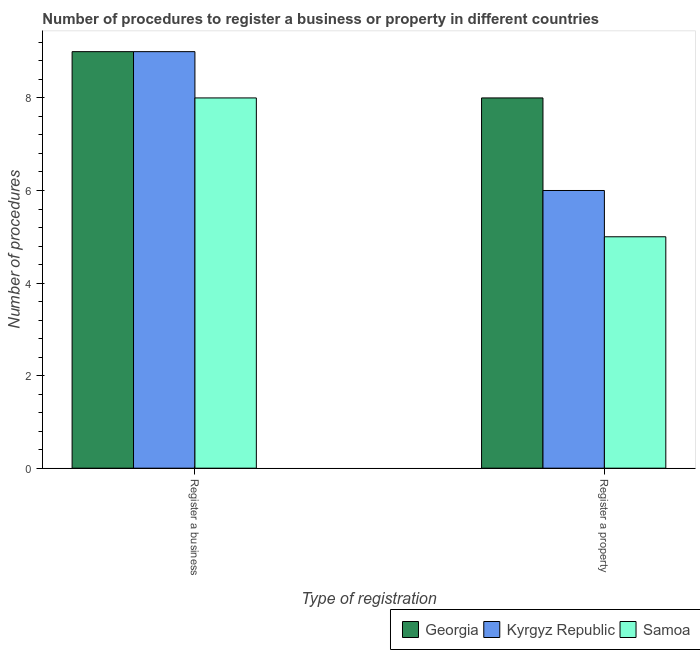How many groups of bars are there?
Provide a short and direct response. 2. Are the number of bars on each tick of the X-axis equal?
Provide a short and direct response. Yes. What is the label of the 1st group of bars from the left?
Give a very brief answer. Register a business. What is the number of procedures to register a business in Samoa?
Make the answer very short. 8. Across all countries, what is the maximum number of procedures to register a property?
Ensure brevity in your answer.  8. Across all countries, what is the minimum number of procedures to register a property?
Give a very brief answer. 5. In which country was the number of procedures to register a business maximum?
Your response must be concise. Georgia. In which country was the number of procedures to register a business minimum?
Keep it short and to the point. Samoa. What is the total number of procedures to register a property in the graph?
Keep it short and to the point. 19. What is the difference between the number of procedures to register a property in Samoa and that in Kyrgyz Republic?
Give a very brief answer. -1. What is the difference between the number of procedures to register a business in Georgia and the number of procedures to register a property in Kyrgyz Republic?
Keep it short and to the point. 3. What is the average number of procedures to register a business per country?
Provide a short and direct response. 8.67. What is the difference between the number of procedures to register a property and number of procedures to register a business in Kyrgyz Republic?
Offer a very short reply. -3. What is the ratio of the number of procedures to register a business in Samoa to that in Kyrgyz Republic?
Your answer should be compact. 0.89. Is the number of procedures to register a property in Kyrgyz Republic less than that in Georgia?
Your answer should be compact. Yes. In how many countries, is the number of procedures to register a property greater than the average number of procedures to register a property taken over all countries?
Give a very brief answer. 1. What does the 1st bar from the left in Register a business represents?
Offer a very short reply. Georgia. What does the 1st bar from the right in Register a property represents?
Your response must be concise. Samoa. How many countries are there in the graph?
Provide a short and direct response. 3. Are the values on the major ticks of Y-axis written in scientific E-notation?
Your response must be concise. No. What is the title of the graph?
Ensure brevity in your answer.  Number of procedures to register a business or property in different countries. Does "Russian Federation" appear as one of the legend labels in the graph?
Offer a terse response. No. What is the label or title of the X-axis?
Provide a short and direct response. Type of registration. What is the label or title of the Y-axis?
Keep it short and to the point. Number of procedures. What is the Number of procedures in Georgia in Register a property?
Provide a succinct answer. 8. What is the Number of procedures in Kyrgyz Republic in Register a property?
Provide a short and direct response. 6. Across all Type of registration, what is the maximum Number of procedures in Georgia?
Ensure brevity in your answer.  9. Across all Type of registration, what is the minimum Number of procedures of Georgia?
Ensure brevity in your answer.  8. Across all Type of registration, what is the minimum Number of procedures in Kyrgyz Republic?
Keep it short and to the point. 6. Across all Type of registration, what is the minimum Number of procedures in Samoa?
Your answer should be very brief. 5. What is the difference between the Number of procedures of Georgia in Register a business and that in Register a property?
Your answer should be compact. 1. What is the difference between the Number of procedures in Kyrgyz Republic in Register a business and that in Register a property?
Your answer should be very brief. 3. What is the difference between the Number of procedures in Samoa in Register a business and that in Register a property?
Keep it short and to the point. 3. What is the difference between the Number of procedures in Georgia in Register a business and the Number of procedures in Samoa in Register a property?
Provide a succinct answer. 4. What is the average Number of procedures of Georgia per Type of registration?
Provide a short and direct response. 8.5. What is the difference between the Number of procedures of Georgia and Number of procedures of Kyrgyz Republic in Register a business?
Your response must be concise. 0. What is the difference between the Number of procedures of Georgia and Number of procedures of Samoa in Register a business?
Ensure brevity in your answer.  1. What is the difference between the Number of procedures in Kyrgyz Republic and Number of procedures in Samoa in Register a business?
Make the answer very short. 1. What is the difference between the Number of procedures of Georgia and Number of procedures of Samoa in Register a property?
Provide a short and direct response. 3. What is the difference between the Number of procedures in Kyrgyz Republic and Number of procedures in Samoa in Register a property?
Provide a succinct answer. 1. What is the ratio of the Number of procedures in Samoa in Register a business to that in Register a property?
Make the answer very short. 1.6. 